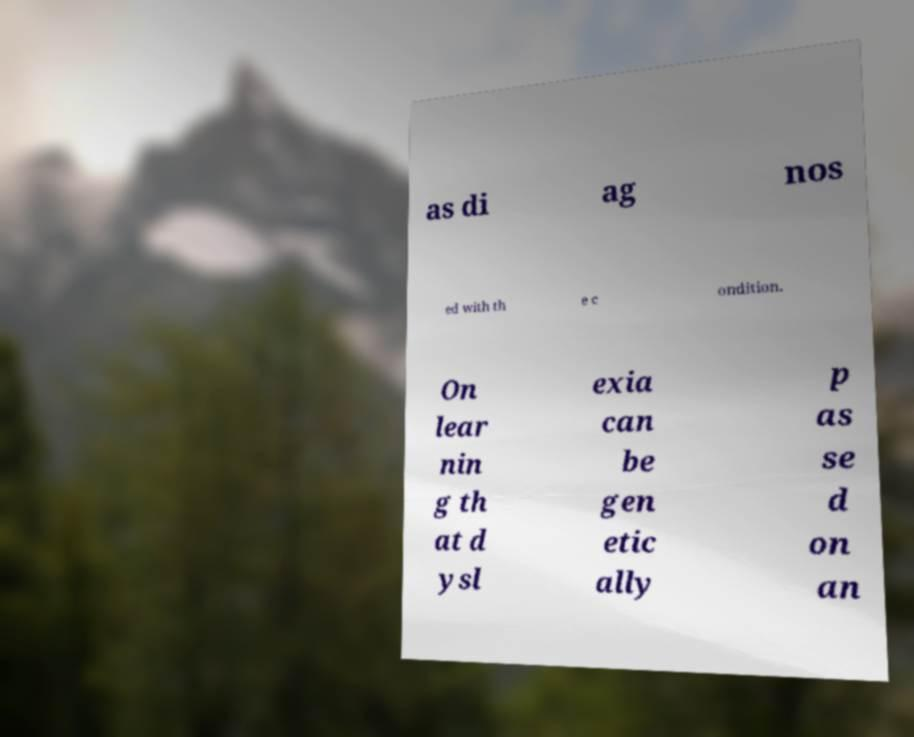Could you extract and type out the text from this image? as di ag nos ed with th e c ondition. On lear nin g th at d ysl exia can be gen etic ally p as se d on an 